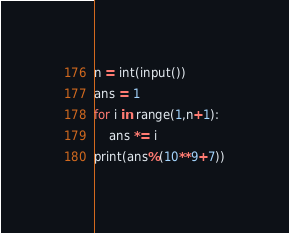<code> <loc_0><loc_0><loc_500><loc_500><_Python_>n = int(input())
ans = 1
for i in range(1,n+1):
    ans *= i
print(ans%(10**9+7))</code> 